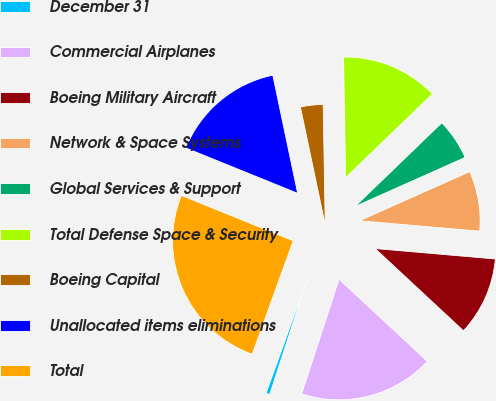Convert chart. <chart><loc_0><loc_0><loc_500><loc_500><pie_chart><fcel>December 31<fcel>Commercial Airplanes<fcel>Boeing Military Aircraft<fcel>Network & Space Systems<fcel>Global Services & Support<fcel>Total Defense Space & Security<fcel>Boeing Capital<fcel>Unallocated items eliminations<fcel>Total<nl><fcel>0.52%<fcel>18.08%<fcel>10.55%<fcel>8.05%<fcel>5.54%<fcel>13.06%<fcel>3.03%<fcel>15.57%<fcel>25.6%<nl></chart> 